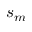Convert formula to latex. <formula><loc_0><loc_0><loc_500><loc_500>s _ { m }</formula> 